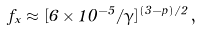Convert formula to latex. <formula><loc_0><loc_0><loc_500><loc_500>f _ { x } \approx [ 6 \times 1 0 ^ { - 5 } / \gamma ] ^ { ( 3 - p ) / 2 } \, ,</formula> 